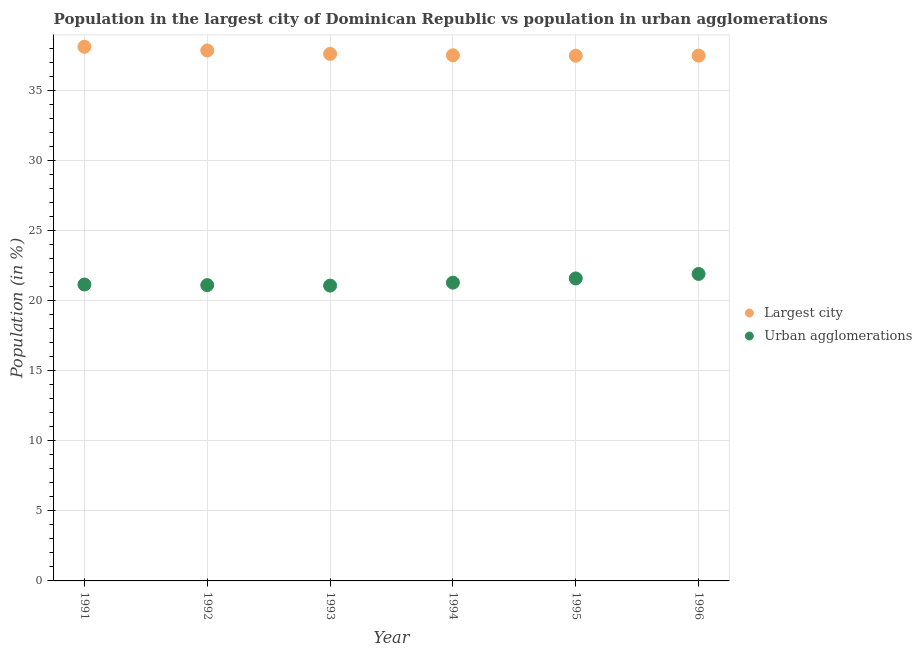Is the number of dotlines equal to the number of legend labels?
Your answer should be very brief. Yes. What is the population in urban agglomerations in 1994?
Offer a terse response. 21.28. Across all years, what is the maximum population in urban agglomerations?
Your response must be concise. 21.9. Across all years, what is the minimum population in urban agglomerations?
Your answer should be very brief. 21.07. In which year was the population in urban agglomerations maximum?
Make the answer very short. 1996. In which year was the population in urban agglomerations minimum?
Offer a very short reply. 1993. What is the total population in the largest city in the graph?
Ensure brevity in your answer.  225.97. What is the difference between the population in urban agglomerations in 1991 and that in 1993?
Provide a succinct answer. 0.08. What is the difference between the population in the largest city in 1993 and the population in urban agglomerations in 1991?
Your response must be concise. 16.45. What is the average population in the largest city per year?
Offer a terse response. 37.66. In the year 1992, what is the difference between the population in urban agglomerations and population in the largest city?
Keep it short and to the point. -16.74. In how many years, is the population in urban agglomerations greater than 7 %?
Ensure brevity in your answer.  6. What is the ratio of the population in urban agglomerations in 1993 to that in 1995?
Offer a terse response. 0.98. What is the difference between the highest and the second highest population in urban agglomerations?
Keep it short and to the point. 0.32. What is the difference between the highest and the lowest population in the largest city?
Give a very brief answer. 0.64. Does the population in the largest city monotonically increase over the years?
Offer a terse response. No. How many years are there in the graph?
Give a very brief answer. 6. What is the difference between two consecutive major ticks on the Y-axis?
Ensure brevity in your answer.  5. Are the values on the major ticks of Y-axis written in scientific E-notation?
Give a very brief answer. No. How many legend labels are there?
Keep it short and to the point. 2. How are the legend labels stacked?
Keep it short and to the point. Vertical. What is the title of the graph?
Keep it short and to the point. Population in the largest city of Dominican Republic vs population in urban agglomerations. What is the label or title of the X-axis?
Your answer should be compact. Year. What is the Population (in %) of Largest city in 1991?
Your answer should be very brief. 38.1. What is the Population (in %) of Urban agglomerations in 1991?
Make the answer very short. 21.14. What is the Population (in %) of Largest city in 1992?
Keep it short and to the point. 37.84. What is the Population (in %) in Urban agglomerations in 1992?
Your response must be concise. 21.1. What is the Population (in %) in Largest city in 1993?
Offer a terse response. 37.59. What is the Population (in %) in Urban agglomerations in 1993?
Provide a succinct answer. 21.07. What is the Population (in %) of Largest city in 1994?
Your answer should be compact. 37.49. What is the Population (in %) in Urban agglomerations in 1994?
Offer a terse response. 21.28. What is the Population (in %) in Largest city in 1995?
Your answer should be very brief. 37.47. What is the Population (in %) in Urban agglomerations in 1995?
Offer a terse response. 21.58. What is the Population (in %) in Largest city in 1996?
Offer a very short reply. 37.47. What is the Population (in %) of Urban agglomerations in 1996?
Keep it short and to the point. 21.9. Across all years, what is the maximum Population (in %) in Largest city?
Provide a succinct answer. 38.1. Across all years, what is the maximum Population (in %) in Urban agglomerations?
Your response must be concise. 21.9. Across all years, what is the minimum Population (in %) of Largest city?
Make the answer very short. 37.47. Across all years, what is the minimum Population (in %) of Urban agglomerations?
Keep it short and to the point. 21.07. What is the total Population (in %) of Largest city in the graph?
Offer a very short reply. 225.97. What is the total Population (in %) in Urban agglomerations in the graph?
Keep it short and to the point. 128.07. What is the difference between the Population (in %) of Largest city in 1991 and that in 1992?
Ensure brevity in your answer.  0.26. What is the difference between the Population (in %) of Urban agglomerations in 1991 and that in 1992?
Offer a very short reply. 0.04. What is the difference between the Population (in %) in Largest city in 1991 and that in 1993?
Offer a terse response. 0.51. What is the difference between the Population (in %) of Urban agglomerations in 1991 and that in 1993?
Your answer should be very brief. 0.08. What is the difference between the Population (in %) in Largest city in 1991 and that in 1994?
Your response must be concise. 0.61. What is the difference between the Population (in %) of Urban agglomerations in 1991 and that in 1994?
Offer a very short reply. -0.13. What is the difference between the Population (in %) of Largest city in 1991 and that in 1995?
Your response must be concise. 0.64. What is the difference between the Population (in %) in Urban agglomerations in 1991 and that in 1995?
Your answer should be compact. -0.43. What is the difference between the Population (in %) in Largest city in 1991 and that in 1996?
Offer a terse response. 0.63. What is the difference between the Population (in %) in Urban agglomerations in 1991 and that in 1996?
Make the answer very short. -0.75. What is the difference between the Population (in %) of Largest city in 1992 and that in 1993?
Offer a very short reply. 0.25. What is the difference between the Population (in %) in Urban agglomerations in 1992 and that in 1993?
Give a very brief answer. 0.04. What is the difference between the Population (in %) of Largest city in 1992 and that in 1994?
Keep it short and to the point. 0.35. What is the difference between the Population (in %) in Urban agglomerations in 1992 and that in 1994?
Provide a succinct answer. -0.18. What is the difference between the Population (in %) of Largest city in 1992 and that in 1995?
Offer a very short reply. 0.37. What is the difference between the Population (in %) of Urban agglomerations in 1992 and that in 1995?
Your response must be concise. -0.48. What is the difference between the Population (in %) in Largest city in 1992 and that in 1996?
Keep it short and to the point. 0.37. What is the difference between the Population (in %) in Urban agglomerations in 1992 and that in 1996?
Provide a short and direct response. -0.8. What is the difference between the Population (in %) in Largest city in 1993 and that in 1994?
Your answer should be compact. 0.1. What is the difference between the Population (in %) of Urban agglomerations in 1993 and that in 1994?
Provide a short and direct response. -0.21. What is the difference between the Population (in %) of Largest city in 1993 and that in 1995?
Offer a terse response. 0.13. What is the difference between the Population (in %) in Urban agglomerations in 1993 and that in 1995?
Offer a terse response. -0.51. What is the difference between the Population (in %) of Largest city in 1993 and that in 1996?
Provide a short and direct response. 0.12. What is the difference between the Population (in %) in Urban agglomerations in 1993 and that in 1996?
Ensure brevity in your answer.  -0.83. What is the difference between the Population (in %) in Largest city in 1994 and that in 1995?
Keep it short and to the point. 0.03. What is the difference between the Population (in %) of Urban agglomerations in 1994 and that in 1995?
Ensure brevity in your answer.  -0.3. What is the difference between the Population (in %) in Largest city in 1994 and that in 1996?
Keep it short and to the point. 0.02. What is the difference between the Population (in %) of Urban agglomerations in 1994 and that in 1996?
Provide a short and direct response. -0.62. What is the difference between the Population (in %) of Largest city in 1995 and that in 1996?
Provide a short and direct response. -0.01. What is the difference between the Population (in %) of Urban agglomerations in 1995 and that in 1996?
Provide a short and direct response. -0.32. What is the difference between the Population (in %) in Largest city in 1991 and the Population (in %) in Urban agglomerations in 1992?
Offer a very short reply. 17. What is the difference between the Population (in %) of Largest city in 1991 and the Population (in %) of Urban agglomerations in 1993?
Your answer should be very brief. 17.03. What is the difference between the Population (in %) in Largest city in 1991 and the Population (in %) in Urban agglomerations in 1994?
Keep it short and to the point. 16.82. What is the difference between the Population (in %) of Largest city in 1991 and the Population (in %) of Urban agglomerations in 1995?
Provide a short and direct response. 16.52. What is the difference between the Population (in %) of Largest city in 1991 and the Population (in %) of Urban agglomerations in 1996?
Keep it short and to the point. 16.2. What is the difference between the Population (in %) of Largest city in 1992 and the Population (in %) of Urban agglomerations in 1993?
Ensure brevity in your answer.  16.77. What is the difference between the Population (in %) in Largest city in 1992 and the Population (in %) in Urban agglomerations in 1994?
Give a very brief answer. 16.56. What is the difference between the Population (in %) of Largest city in 1992 and the Population (in %) of Urban agglomerations in 1995?
Provide a succinct answer. 16.26. What is the difference between the Population (in %) of Largest city in 1992 and the Population (in %) of Urban agglomerations in 1996?
Your response must be concise. 15.94. What is the difference between the Population (in %) in Largest city in 1993 and the Population (in %) in Urban agglomerations in 1994?
Ensure brevity in your answer.  16.32. What is the difference between the Population (in %) of Largest city in 1993 and the Population (in %) of Urban agglomerations in 1995?
Your answer should be compact. 16.02. What is the difference between the Population (in %) in Largest city in 1993 and the Population (in %) in Urban agglomerations in 1996?
Give a very brief answer. 15.7. What is the difference between the Population (in %) of Largest city in 1994 and the Population (in %) of Urban agglomerations in 1995?
Make the answer very short. 15.92. What is the difference between the Population (in %) of Largest city in 1994 and the Population (in %) of Urban agglomerations in 1996?
Give a very brief answer. 15.6. What is the difference between the Population (in %) of Largest city in 1995 and the Population (in %) of Urban agglomerations in 1996?
Provide a succinct answer. 15.57. What is the average Population (in %) of Largest city per year?
Provide a succinct answer. 37.66. What is the average Population (in %) in Urban agglomerations per year?
Give a very brief answer. 21.34. In the year 1991, what is the difference between the Population (in %) of Largest city and Population (in %) of Urban agglomerations?
Give a very brief answer. 16.96. In the year 1992, what is the difference between the Population (in %) of Largest city and Population (in %) of Urban agglomerations?
Keep it short and to the point. 16.74. In the year 1993, what is the difference between the Population (in %) in Largest city and Population (in %) in Urban agglomerations?
Offer a terse response. 16.53. In the year 1994, what is the difference between the Population (in %) in Largest city and Population (in %) in Urban agglomerations?
Offer a terse response. 16.22. In the year 1995, what is the difference between the Population (in %) of Largest city and Population (in %) of Urban agglomerations?
Give a very brief answer. 15.89. In the year 1996, what is the difference between the Population (in %) in Largest city and Population (in %) in Urban agglomerations?
Ensure brevity in your answer.  15.57. What is the ratio of the Population (in %) in Urban agglomerations in 1991 to that in 1992?
Your answer should be very brief. 1. What is the ratio of the Population (in %) of Largest city in 1991 to that in 1993?
Give a very brief answer. 1.01. What is the ratio of the Population (in %) in Urban agglomerations in 1991 to that in 1993?
Provide a short and direct response. 1. What is the ratio of the Population (in %) in Largest city in 1991 to that in 1994?
Offer a very short reply. 1.02. What is the ratio of the Population (in %) in Urban agglomerations in 1991 to that in 1995?
Ensure brevity in your answer.  0.98. What is the ratio of the Population (in %) in Largest city in 1991 to that in 1996?
Your answer should be very brief. 1.02. What is the ratio of the Population (in %) in Urban agglomerations in 1991 to that in 1996?
Give a very brief answer. 0.97. What is the ratio of the Population (in %) in Urban agglomerations in 1992 to that in 1993?
Provide a short and direct response. 1. What is the ratio of the Population (in %) of Largest city in 1992 to that in 1994?
Provide a short and direct response. 1.01. What is the ratio of the Population (in %) of Largest city in 1992 to that in 1995?
Give a very brief answer. 1.01. What is the ratio of the Population (in %) of Urban agglomerations in 1992 to that in 1995?
Make the answer very short. 0.98. What is the ratio of the Population (in %) of Largest city in 1992 to that in 1996?
Give a very brief answer. 1.01. What is the ratio of the Population (in %) in Urban agglomerations in 1992 to that in 1996?
Offer a very short reply. 0.96. What is the ratio of the Population (in %) of Largest city in 1993 to that in 1994?
Give a very brief answer. 1. What is the ratio of the Population (in %) in Largest city in 1993 to that in 1995?
Offer a terse response. 1. What is the ratio of the Population (in %) of Urban agglomerations in 1993 to that in 1995?
Provide a succinct answer. 0.98. What is the ratio of the Population (in %) in Largest city in 1993 to that in 1996?
Your response must be concise. 1. What is the ratio of the Population (in %) in Urban agglomerations in 1994 to that in 1995?
Provide a short and direct response. 0.99. What is the ratio of the Population (in %) of Largest city in 1994 to that in 1996?
Your answer should be compact. 1. What is the ratio of the Population (in %) of Urban agglomerations in 1994 to that in 1996?
Your response must be concise. 0.97. What is the ratio of the Population (in %) in Urban agglomerations in 1995 to that in 1996?
Make the answer very short. 0.99. What is the difference between the highest and the second highest Population (in %) of Largest city?
Offer a terse response. 0.26. What is the difference between the highest and the second highest Population (in %) in Urban agglomerations?
Offer a terse response. 0.32. What is the difference between the highest and the lowest Population (in %) in Largest city?
Your response must be concise. 0.64. What is the difference between the highest and the lowest Population (in %) of Urban agglomerations?
Your response must be concise. 0.83. 